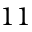<formula> <loc_0><loc_0><loc_500><loc_500>1 1</formula> 